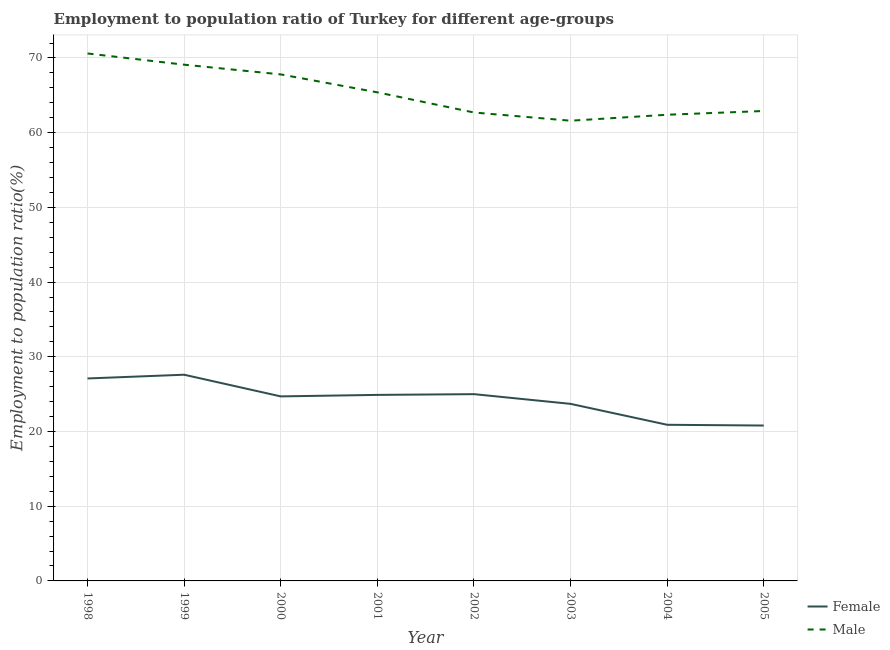Does the line corresponding to employment to population ratio(male) intersect with the line corresponding to employment to population ratio(female)?
Ensure brevity in your answer.  No. Is the number of lines equal to the number of legend labels?
Offer a terse response. Yes. What is the employment to population ratio(male) in 1998?
Ensure brevity in your answer.  70.6. Across all years, what is the maximum employment to population ratio(male)?
Ensure brevity in your answer.  70.6. Across all years, what is the minimum employment to population ratio(female)?
Your answer should be very brief. 20.8. In which year was the employment to population ratio(female) minimum?
Provide a short and direct response. 2005. What is the total employment to population ratio(female) in the graph?
Keep it short and to the point. 194.7. What is the difference between the employment to population ratio(female) in 2001 and that in 2003?
Offer a very short reply. 1.2. What is the difference between the employment to population ratio(male) in 2004 and the employment to population ratio(female) in 2000?
Provide a succinct answer. 37.7. What is the average employment to population ratio(female) per year?
Offer a very short reply. 24.34. In the year 2005, what is the difference between the employment to population ratio(male) and employment to population ratio(female)?
Keep it short and to the point. 42.1. In how many years, is the employment to population ratio(male) greater than 32 %?
Make the answer very short. 8. What is the ratio of the employment to population ratio(female) in 1998 to that in 2004?
Provide a succinct answer. 1.3. What is the difference between the highest and the second highest employment to population ratio(female)?
Provide a short and direct response. 0.5. What is the difference between the highest and the lowest employment to population ratio(male)?
Your answer should be compact. 9. In how many years, is the employment to population ratio(male) greater than the average employment to population ratio(male) taken over all years?
Give a very brief answer. 4. How many lines are there?
Provide a short and direct response. 2. How many years are there in the graph?
Your answer should be very brief. 8. What is the difference between two consecutive major ticks on the Y-axis?
Your response must be concise. 10. Are the values on the major ticks of Y-axis written in scientific E-notation?
Make the answer very short. No. Does the graph contain any zero values?
Give a very brief answer. No. How are the legend labels stacked?
Keep it short and to the point. Vertical. What is the title of the graph?
Your response must be concise. Employment to population ratio of Turkey for different age-groups. Does "Long-term debt" appear as one of the legend labels in the graph?
Your answer should be compact. No. What is the label or title of the X-axis?
Offer a terse response. Year. What is the label or title of the Y-axis?
Give a very brief answer. Employment to population ratio(%). What is the Employment to population ratio(%) of Female in 1998?
Provide a succinct answer. 27.1. What is the Employment to population ratio(%) in Male in 1998?
Keep it short and to the point. 70.6. What is the Employment to population ratio(%) of Female in 1999?
Keep it short and to the point. 27.6. What is the Employment to population ratio(%) of Male in 1999?
Ensure brevity in your answer.  69.1. What is the Employment to population ratio(%) in Female in 2000?
Make the answer very short. 24.7. What is the Employment to population ratio(%) in Male in 2000?
Ensure brevity in your answer.  67.8. What is the Employment to population ratio(%) in Female in 2001?
Ensure brevity in your answer.  24.9. What is the Employment to population ratio(%) of Male in 2001?
Your response must be concise. 65.4. What is the Employment to population ratio(%) of Male in 2002?
Provide a succinct answer. 62.7. What is the Employment to population ratio(%) in Female in 2003?
Offer a terse response. 23.7. What is the Employment to population ratio(%) of Male in 2003?
Offer a terse response. 61.6. What is the Employment to population ratio(%) of Female in 2004?
Offer a terse response. 20.9. What is the Employment to population ratio(%) in Male in 2004?
Keep it short and to the point. 62.4. What is the Employment to population ratio(%) of Female in 2005?
Provide a succinct answer. 20.8. What is the Employment to population ratio(%) of Male in 2005?
Your answer should be compact. 62.9. Across all years, what is the maximum Employment to population ratio(%) of Female?
Make the answer very short. 27.6. Across all years, what is the maximum Employment to population ratio(%) in Male?
Your answer should be compact. 70.6. Across all years, what is the minimum Employment to population ratio(%) in Female?
Keep it short and to the point. 20.8. Across all years, what is the minimum Employment to population ratio(%) in Male?
Keep it short and to the point. 61.6. What is the total Employment to population ratio(%) of Female in the graph?
Keep it short and to the point. 194.7. What is the total Employment to population ratio(%) of Male in the graph?
Keep it short and to the point. 522.5. What is the difference between the Employment to population ratio(%) in Male in 1998 and that in 1999?
Your response must be concise. 1.5. What is the difference between the Employment to population ratio(%) in Female in 1998 and that in 2001?
Offer a terse response. 2.2. What is the difference between the Employment to population ratio(%) in Male in 1998 and that in 2002?
Offer a terse response. 7.9. What is the difference between the Employment to population ratio(%) of Male in 1998 and that in 2003?
Offer a very short reply. 9. What is the difference between the Employment to population ratio(%) in Female in 1998 and that in 2004?
Your response must be concise. 6.2. What is the difference between the Employment to population ratio(%) in Female in 1998 and that in 2005?
Your answer should be compact. 6.3. What is the difference between the Employment to population ratio(%) of Male in 1998 and that in 2005?
Keep it short and to the point. 7.7. What is the difference between the Employment to population ratio(%) in Male in 1999 and that in 2000?
Provide a succinct answer. 1.3. What is the difference between the Employment to population ratio(%) of Female in 1999 and that in 2002?
Offer a very short reply. 2.6. What is the difference between the Employment to population ratio(%) of Female in 1999 and that in 2005?
Offer a terse response. 6.8. What is the difference between the Employment to population ratio(%) of Female in 2000 and that in 2001?
Offer a very short reply. -0.2. What is the difference between the Employment to population ratio(%) in Male in 2000 and that in 2001?
Your answer should be very brief. 2.4. What is the difference between the Employment to population ratio(%) in Male in 2000 and that in 2003?
Provide a short and direct response. 6.2. What is the difference between the Employment to population ratio(%) in Male in 2000 and that in 2005?
Ensure brevity in your answer.  4.9. What is the difference between the Employment to population ratio(%) of Male in 2001 and that in 2002?
Make the answer very short. 2.7. What is the difference between the Employment to population ratio(%) of Female in 2001 and that in 2003?
Make the answer very short. 1.2. What is the difference between the Employment to population ratio(%) in Male in 2001 and that in 2003?
Offer a terse response. 3.8. What is the difference between the Employment to population ratio(%) of Male in 2002 and that in 2003?
Your response must be concise. 1.1. What is the difference between the Employment to population ratio(%) of Female in 2002 and that in 2004?
Make the answer very short. 4.1. What is the difference between the Employment to population ratio(%) of Male in 2002 and that in 2005?
Provide a short and direct response. -0.2. What is the difference between the Employment to population ratio(%) of Female in 2003 and that in 2004?
Offer a terse response. 2.8. What is the difference between the Employment to population ratio(%) of Male in 2003 and that in 2004?
Provide a short and direct response. -0.8. What is the difference between the Employment to population ratio(%) in Female in 2004 and that in 2005?
Ensure brevity in your answer.  0.1. What is the difference between the Employment to population ratio(%) of Male in 2004 and that in 2005?
Provide a short and direct response. -0.5. What is the difference between the Employment to population ratio(%) of Female in 1998 and the Employment to population ratio(%) of Male in 1999?
Keep it short and to the point. -42. What is the difference between the Employment to population ratio(%) in Female in 1998 and the Employment to population ratio(%) in Male in 2000?
Offer a very short reply. -40.7. What is the difference between the Employment to population ratio(%) of Female in 1998 and the Employment to population ratio(%) of Male in 2001?
Your response must be concise. -38.3. What is the difference between the Employment to population ratio(%) in Female in 1998 and the Employment to population ratio(%) in Male in 2002?
Provide a succinct answer. -35.6. What is the difference between the Employment to population ratio(%) in Female in 1998 and the Employment to population ratio(%) in Male in 2003?
Give a very brief answer. -34.5. What is the difference between the Employment to population ratio(%) of Female in 1998 and the Employment to population ratio(%) of Male in 2004?
Offer a terse response. -35.3. What is the difference between the Employment to population ratio(%) of Female in 1998 and the Employment to population ratio(%) of Male in 2005?
Keep it short and to the point. -35.8. What is the difference between the Employment to population ratio(%) of Female in 1999 and the Employment to population ratio(%) of Male in 2000?
Your response must be concise. -40.2. What is the difference between the Employment to population ratio(%) in Female in 1999 and the Employment to population ratio(%) in Male in 2001?
Provide a short and direct response. -37.8. What is the difference between the Employment to population ratio(%) of Female in 1999 and the Employment to population ratio(%) of Male in 2002?
Your answer should be very brief. -35.1. What is the difference between the Employment to population ratio(%) of Female in 1999 and the Employment to population ratio(%) of Male in 2003?
Keep it short and to the point. -34. What is the difference between the Employment to population ratio(%) of Female in 1999 and the Employment to population ratio(%) of Male in 2004?
Offer a very short reply. -34.8. What is the difference between the Employment to population ratio(%) in Female in 1999 and the Employment to population ratio(%) in Male in 2005?
Keep it short and to the point. -35.3. What is the difference between the Employment to population ratio(%) of Female in 2000 and the Employment to population ratio(%) of Male in 2001?
Ensure brevity in your answer.  -40.7. What is the difference between the Employment to population ratio(%) of Female in 2000 and the Employment to population ratio(%) of Male in 2002?
Your answer should be compact. -38. What is the difference between the Employment to population ratio(%) in Female in 2000 and the Employment to population ratio(%) in Male in 2003?
Keep it short and to the point. -36.9. What is the difference between the Employment to population ratio(%) in Female in 2000 and the Employment to population ratio(%) in Male in 2004?
Offer a very short reply. -37.7. What is the difference between the Employment to population ratio(%) of Female in 2000 and the Employment to population ratio(%) of Male in 2005?
Keep it short and to the point. -38.2. What is the difference between the Employment to population ratio(%) in Female in 2001 and the Employment to population ratio(%) in Male in 2002?
Your response must be concise. -37.8. What is the difference between the Employment to population ratio(%) in Female in 2001 and the Employment to population ratio(%) in Male in 2003?
Provide a succinct answer. -36.7. What is the difference between the Employment to population ratio(%) of Female in 2001 and the Employment to population ratio(%) of Male in 2004?
Make the answer very short. -37.5. What is the difference between the Employment to population ratio(%) of Female in 2001 and the Employment to population ratio(%) of Male in 2005?
Make the answer very short. -38. What is the difference between the Employment to population ratio(%) in Female in 2002 and the Employment to population ratio(%) in Male in 2003?
Your answer should be very brief. -36.6. What is the difference between the Employment to population ratio(%) in Female in 2002 and the Employment to population ratio(%) in Male in 2004?
Your answer should be very brief. -37.4. What is the difference between the Employment to population ratio(%) in Female in 2002 and the Employment to population ratio(%) in Male in 2005?
Your answer should be very brief. -37.9. What is the difference between the Employment to population ratio(%) in Female in 2003 and the Employment to population ratio(%) in Male in 2004?
Your answer should be compact. -38.7. What is the difference between the Employment to population ratio(%) of Female in 2003 and the Employment to population ratio(%) of Male in 2005?
Make the answer very short. -39.2. What is the difference between the Employment to population ratio(%) of Female in 2004 and the Employment to population ratio(%) of Male in 2005?
Provide a short and direct response. -42. What is the average Employment to population ratio(%) in Female per year?
Give a very brief answer. 24.34. What is the average Employment to population ratio(%) of Male per year?
Your answer should be very brief. 65.31. In the year 1998, what is the difference between the Employment to population ratio(%) in Female and Employment to population ratio(%) in Male?
Offer a very short reply. -43.5. In the year 1999, what is the difference between the Employment to population ratio(%) of Female and Employment to population ratio(%) of Male?
Offer a very short reply. -41.5. In the year 2000, what is the difference between the Employment to population ratio(%) in Female and Employment to population ratio(%) in Male?
Make the answer very short. -43.1. In the year 2001, what is the difference between the Employment to population ratio(%) of Female and Employment to population ratio(%) of Male?
Offer a very short reply. -40.5. In the year 2002, what is the difference between the Employment to population ratio(%) of Female and Employment to population ratio(%) of Male?
Provide a succinct answer. -37.7. In the year 2003, what is the difference between the Employment to population ratio(%) of Female and Employment to population ratio(%) of Male?
Ensure brevity in your answer.  -37.9. In the year 2004, what is the difference between the Employment to population ratio(%) in Female and Employment to population ratio(%) in Male?
Keep it short and to the point. -41.5. In the year 2005, what is the difference between the Employment to population ratio(%) of Female and Employment to population ratio(%) of Male?
Keep it short and to the point. -42.1. What is the ratio of the Employment to population ratio(%) in Female in 1998 to that in 1999?
Make the answer very short. 0.98. What is the ratio of the Employment to population ratio(%) in Male in 1998 to that in 1999?
Provide a succinct answer. 1.02. What is the ratio of the Employment to population ratio(%) in Female in 1998 to that in 2000?
Give a very brief answer. 1.1. What is the ratio of the Employment to population ratio(%) in Male in 1998 to that in 2000?
Make the answer very short. 1.04. What is the ratio of the Employment to population ratio(%) in Female in 1998 to that in 2001?
Offer a very short reply. 1.09. What is the ratio of the Employment to population ratio(%) in Male in 1998 to that in 2001?
Your answer should be compact. 1.08. What is the ratio of the Employment to population ratio(%) in Female in 1998 to that in 2002?
Make the answer very short. 1.08. What is the ratio of the Employment to population ratio(%) in Male in 1998 to that in 2002?
Provide a succinct answer. 1.13. What is the ratio of the Employment to population ratio(%) of Female in 1998 to that in 2003?
Ensure brevity in your answer.  1.14. What is the ratio of the Employment to population ratio(%) in Male in 1998 to that in 2003?
Offer a very short reply. 1.15. What is the ratio of the Employment to population ratio(%) in Female in 1998 to that in 2004?
Your answer should be compact. 1.3. What is the ratio of the Employment to population ratio(%) of Male in 1998 to that in 2004?
Make the answer very short. 1.13. What is the ratio of the Employment to population ratio(%) in Female in 1998 to that in 2005?
Offer a terse response. 1.3. What is the ratio of the Employment to population ratio(%) in Male in 1998 to that in 2005?
Your response must be concise. 1.12. What is the ratio of the Employment to population ratio(%) in Female in 1999 to that in 2000?
Make the answer very short. 1.12. What is the ratio of the Employment to population ratio(%) in Male in 1999 to that in 2000?
Provide a short and direct response. 1.02. What is the ratio of the Employment to population ratio(%) of Female in 1999 to that in 2001?
Keep it short and to the point. 1.11. What is the ratio of the Employment to population ratio(%) of Male in 1999 to that in 2001?
Give a very brief answer. 1.06. What is the ratio of the Employment to population ratio(%) of Female in 1999 to that in 2002?
Offer a terse response. 1.1. What is the ratio of the Employment to population ratio(%) in Male in 1999 to that in 2002?
Keep it short and to the point. 1.1. What is the ratio of the Employment to population ratio(%) of Female in 1999 to that in 2003?
Your response must be concise. 1.16. What is the ratio of the Employment to population ratio(%) of Male in 1999 to that in 2003?
Offer a very short reply. 1.12. What is the ratio of the Employment to population ratio(%) in Female in 1999 to that in 2004?
Provide a short and direct response. 1.32. What is the ratio of the Employment to population ratio(%) in Male in 1999 to that in 2004?
Your response must be concise. 1.11. What is the ratio of the Employment to population ratio(%) of Female in 1999 to that in 2005?
Provide a succinct answer. 1.33. What is the ratio of the Employment to population ratio(%) of Male in 1999 to that in 2005?
Provide a short and direct response. 1.1. What is the ratio of the Employment to population ratio(%) in Male in 2000 to that in 2001?
Your response must be concise. 1.04. What is the ratio of the Employment to population ratio(%) in Male in 2000 to that in 2002?
Make the answer very short. 1.08. What is the ratio of the Employment to population ratio(%) of Female in 2000 to that in 2003?
Your response must be concise. 1.04. What is the ratio of the Employment to population ratio(%) of Male in 2000 to that in 2003?
Your answer should be compact. 1.1. What is the ratio of the Employment to population ratio(%) in Female in 2000 to that in 2004?
Give a very brief answer. 1.18. What is the ratio of the Employment to population ratio(%) of Male in 2000 to that in 2004?
Offer a very short reply. 1.09. What is the ratio of the Employment to population ratio(%) in Female in 2000 to that in 2005?
Your answer should be compact. 1.19. What is the ratio of the Employment to population ratio(%) in Male in 2000 to that in 2005?
Ensure brevity in your answer.  1.08. What is the ratio of the Employment to population ratio(%) in Female in 2001 to that in 2002?
Your response must be concise. 1. What is the ratio of the Employment to population ratio(%) in Male in 2001 to that in 2002?
Your answer should be compact. 1.04. What is the ratio of the Employment to population ratio(%) in Female in 2001 to that in 2003?
Ensure brevity in your answer.  1.05. What is the ratio of the Employment to population ratio(%) of Male in 2001 to that in 2003?
Provide a short and direct response. 1.06. What is the ratio of the Employment to population ratio(%) of Female in 2001 to that in 2004?
Offer a very short reply. 1.19. What is the ratio of the Employment to population ratio(%) in Male in 2001 to that in 2004?
Provide a succinct answer. 1.05. What is the ratio of the Employment to population ratio(%) in Female in 2001 to that in 2005?
Your response must be concise. 1.2. What is the ratio of the Employment to population ratio(%) in Male in 2001 to that in 2005?
Ensure brevity in your answer.  1.04. What is the ratio of the Employment to population ratio(%) of Female in 2002 to that in 2003?
Keep it short and to the point. 1.05. What is the ratio of the Employment to population ratio(%) of Male in 2002 to that in 2003?
Offer a terse response. 1.02. What is the ratio of the Employment to population ratio(%) of Female in 2002 to that in 2004?
Make the answer very short. 1.2. What is the ratio of the Employment to population ratio(%) in Female in 2002 to that in 2005?
Provide a short and direct response. 1.2. What is the ratio of the Employment to population ratio(%) in Male in 2002 to that in 2005?
Provide a short and direct response. 1. What is the ratio of the Employment to population ratio(%) in Female in 2003 to that in 2004?
Keep it short and to the point. 1.13. What is the ratio of the Employment to population ratio(%) in Male in 2003 to that in 2004?
Ensure brevity in your answer.  0.99. What is the ratio of the Employment to population ratio(%) in Female in 2003 to that in 2005?
Your answer should be very brief. 1.14. What is the ratio of the Employment to population ratio(%) in Male in 2003 to that in 2005?
Give a very brief answer. 0.98. What is the ratio of the Employment to population ratio(%) of Female in 2004 to that in 2005?
Your answer should be compact. 1. What is the ratio of the Employment to population ratio(%) of Male in 2004 to that in 2005?
Provide a succinct answer. 0.99. What is the difference between the highest and the lowest Employment to population ratio(%) in Female?
Your answer should be very brief. 6.8. What is the difference between the highest and the lowest Employment to population ratio(%) in Male?
Provide a short and direct response. 9. 